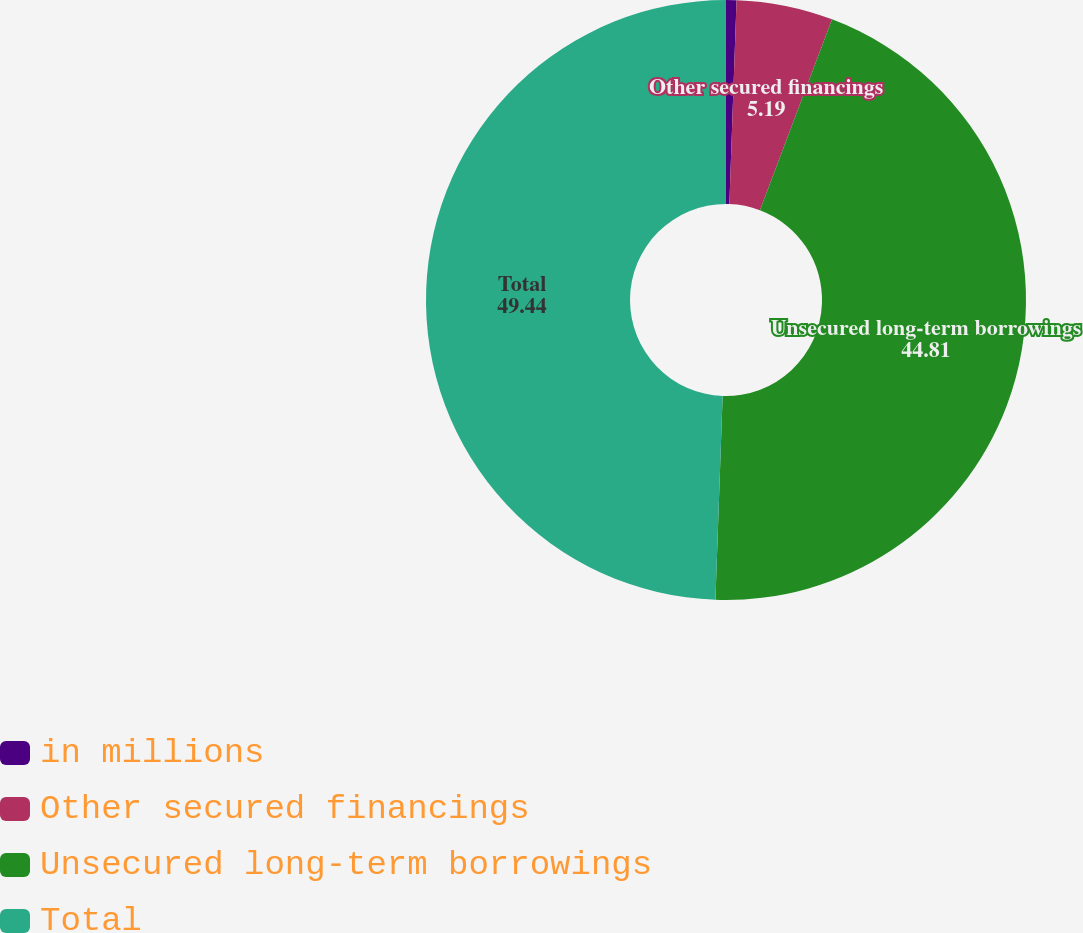Convert chart. <chart><loc_0><loc_0><loc_500><loc_500><pie_chart><fcel>in millions<fcel>Other secured financings<fcel>Unsecured long-term borrowings<fcel>Total<nl><fcel>0.56%<fcel>5.19%<fcel>44.81%<fcel>49.44%<nl></chart> 